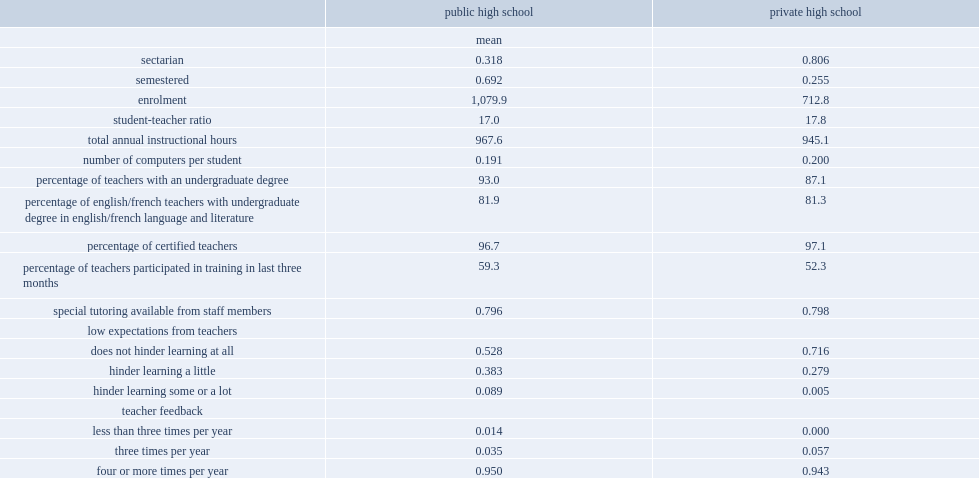Which school had higher student-teacher ratio, private schools or public schools? Private high school. Which school had higher average annual number of instructional hours,private schools or public schools? Public high school. Which school had larger average enrolment, private schools or public schools? Public high school. Which school was more likely to be sectarian,private schools or public schools? Private high school. What were the percentages of principals believed that low teacher expectations of students did not hinder learning at all in the private sector and public sector respectively? 0.716 0.528. 